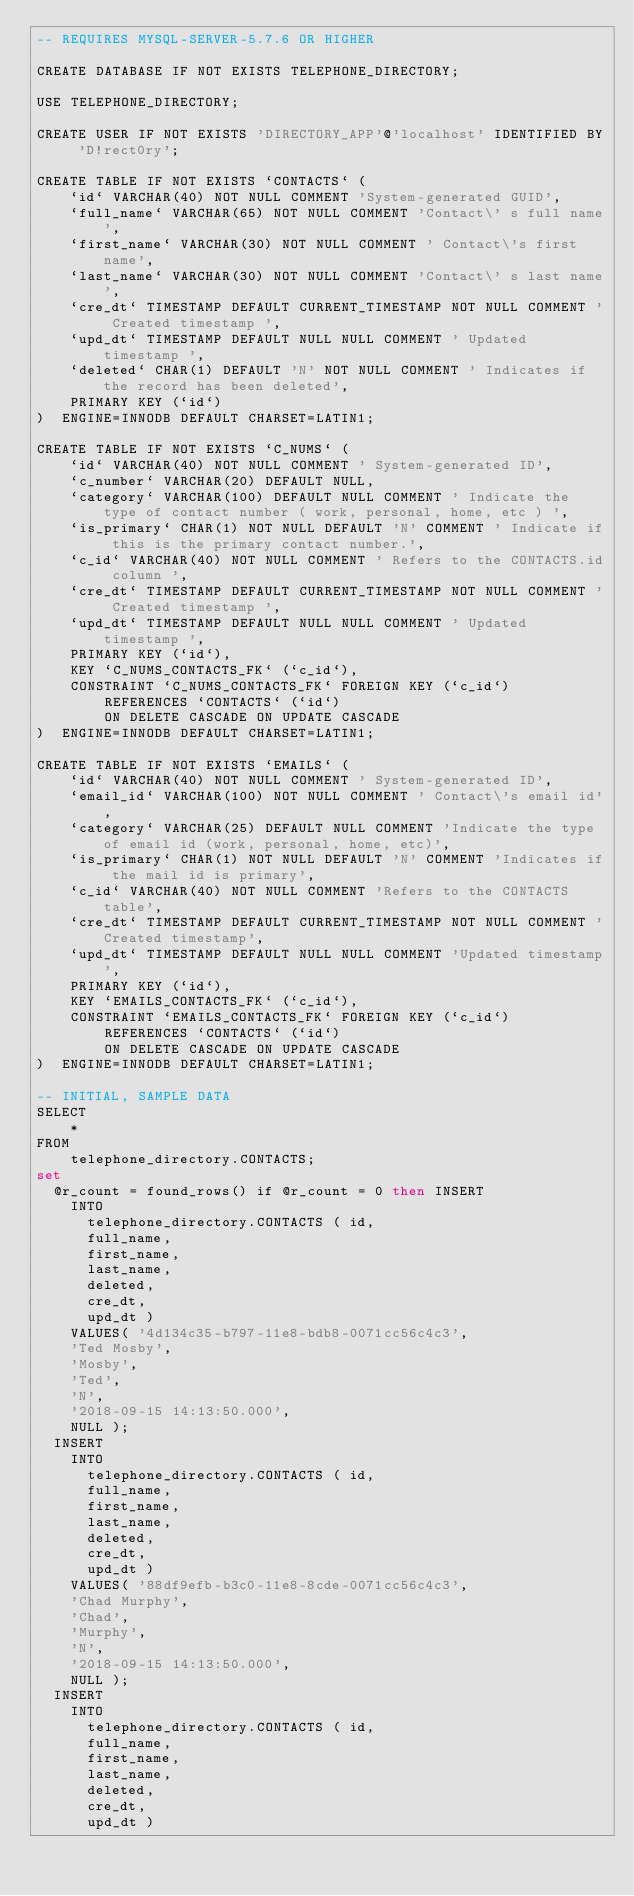Convert code to text. <code><loc_0><loc_0><loc_500><loc_500><_SQL_>-- REQUIRES MYSQL-SERVER-5.7.6 OR HIGHER

CREATE DATABASE IF NOT EXISTS TELEPHONE_DIRECTORY;

USE TELEPHONE_DIRECTORY;

CREATE USER IF NOT EXISTS 'DIRECTORY_APP'@'localhost' IDENTIFIED BY 'D!rect0ry';

CREATE TABLE IF NOT EXISTS `CONTACTS` (
    `id` VARCHAR(40) NOT NULL COMMENT 'System-generated GUID',
    `full_name` VARCHAR(65) NOT NULL COMMENT 'Contact\' s full name',
    `first_name` VARCHAR(30) NOT NULL COMMENT ' Contact\'s first name',
    `last_name` VARCHAR(30) NOT NULL COMMENT 'Contact\' s last name',
    `cre_dt` TIMESTAMP DEFAULT CURRENT_TIMESTAMP NOT NULL COMMENT ' Created timestamp ',
    `upd_dt` TIMESTAMP DEFAULT NULL NULL COMMENT ' Updated timestamp ',
    `deleted` CHAR(1) DEFAULT 'N' NOT NULL COMMENT ' Indicates if the record has been deleted',
    PRIMARY KEY (`id`)
)  ENGINE=INNODB DEFAULT CHARSET=LATIN1;

CREATE TABLE IF NOT EXISTS `C_NUMS` (
    `id` VARCHAR(40) NOT NULL COMMENT ' System-generated ID',
    `c_number` VARCHAR(20) DEFAULT NULL,
    `category` VARCHAR(100) DEFAULT NULL COMMENT ' Indicate the type of contact number ( work, personal, home, etc ) ',
    `is_primary` CHAR(1) NOT NULL DEFAULT 'N' COMMENT ' Indicate if this is the primary contact number.',
    `c_id` VARCHAR(40) NOT NULL COMMENT ' Refers to the CONTACTS.id column ',
    `cre_dt` TIMESTAMP DEFAULT CURRENT_TIMESTAMP NOT NULL COMMENT ' Created timestamp ',
    `upd_dt` TIMESTAMP DEFAULT NULL NULL COMMENT ' Updated timestamp ',
    PRIMARY KEY (`id`),
    KEY `C_NUMS_CONTACTS_FK` (`c_id`),
    CONSTRAINT `C_NUMS_CONTACTS_FK` FOREIGN KEY (`c_id`)
        REFERENCES `CONTACTS` (`id`)
        ON DELETE CASCADE ON UPDATE CASCADE
)  ENGINE=INNODB DEFAULT CHARSET=LATIN1;

CREATE TABLE IF NOT EXISTS `EMAILS` (
    `id` VARCHAR(40) NOT NULL COMMENT ' System-generated ID',
    `email_id` VARCHAR(100) NOT NULL COMMENT ' Contact\'s email id',
    `category` VARCHAR(25) DEFAULT NULL COMMENT 'Indicate the type of email id (work, personal, home, etc)',
    `is_primary` CHAR(1) NOT NULL DEFAULT 'N' COMMENT 'Indicates if the mail id is primary',
    `c_id` VARCHAR(40) NOT NULL COMMENT 'Refers to the CONTACTS table',
    `cre_dt` TIMESTAMP DEFAULT CURRENT_TIMESTAMP NOT NULL COMMENT 'Created timestamp',
    `upd_dt` TIMESTAMP DEFAULT NULL NULL COMMENT 'Updated timestamp',
    PRIMARY KEY (`id`),
    KEY `EMAILS_CONTACTS_FK` (`c_id`),
    CONSTRAINT `EMAILS_CONTACTS_FK` FOREIGN KEY (`c_id`)
        REFERENCES `CONTACTS` (`id`)
        ON DELETE CASCADE ON UPDATE CASCADE
)  ENGINE=INNODB DEFAULT CHARSET=LATIN1;

-- INITIAL, SAMPLE DATA
SELECT 
    *
FROM
    telephone_directory.CONTACTS;
set
	@r_count = found_rows() if @r_count = 0 then INSERT
		INTO
			telephone_directory.CONTACTS ( id,
			full_name,
			first_name,
			last_name,
			deleted,
			cre_dt,
			upd_dt )
		VALUES( '4d134c35-b797-11e8-bdb8-0071cc56c4c3',
		'Ted Mosby',
		'Mosby',
		'Ted',
		'N',
		'2018-09-15 14:13:50.000',
		NULL );
	INSERT
		INTO
			telephone_directory.CONTACTS ( id,
			full_name,
			first_name,
			last_name,
			deleted,
			cre_dt,
			upd_dt )
		VALUES( '88df9efb-b3c0-11e8-8cde-0071cc56c4c3',
		'Chad Murphy',
		'Chad',
		'Murphy',
		'N',
		'2018-09-15 14:13:50.000',
		NULL );
	INSERT
		INTO
			telephone_directory.CONTACTS ( id,
			full_name,
			first_name,
			last_name,
			deleted,
			cre_dt,
			upd_dt )</code> 